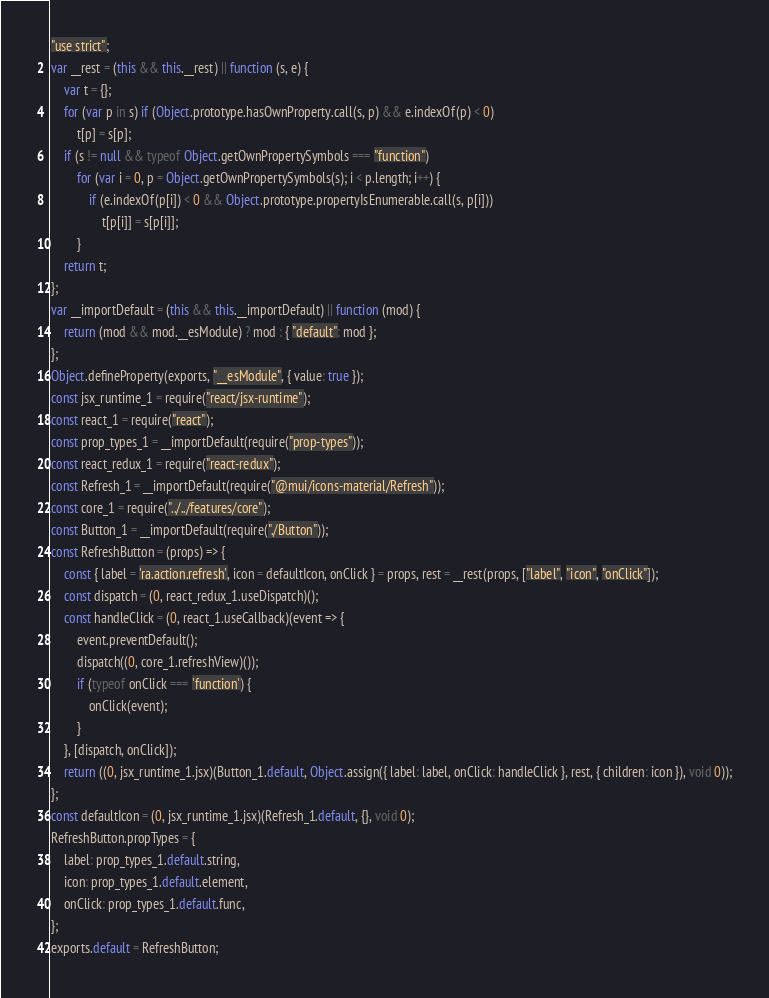Convert code to text. <code><loc_0><loc_0><loc_500><loc_500><_JavaScript_>"use strict";
var __rest = (this && this.__rest) || function (s, e) {
    var t = {};
    for (var p in s) if (Object.prototype.hasOwnProperty.call(s, p) && e.indexOf(p) < 0)
        t[p] = s[p];
    if (s != null && typeof Object.getOwnPropertySymbols === "function")
        for (var i = 0, p = Object.getOwnPropertySymbols(s); i < p.length; i++) {
            if (e.indexOf(p[i]) < 0 && Object.prototype.propertyIsEnumerable.call(s, p[i]))
                t[p[i]] = s[p[i]];
        }
    return t;
};
var __importDefault = (this && this.__importDefault) || function (mod) {
    return (mod && mod.__esModule) ? mod : { "default": mod };
};
Object.defineProperty(exports, "__esModule", { value: true });
const jsx_runtime_1 = require("react/jsx-runtime");
const react_1 = require("react");
const prop_types_1 = __importDefault(require("prop-types"));
const react_redux_1 = require("react-redux");
const Refresh_1 = __importDefault(require("@mui/icons-material/Refresh"));
const core_1 = require("../../features/core");
const Button_1 = __importDefault(require("./Button"));
const RefreshButton = (props) => {
    const { label = 'ra.action.refresh', icon = defaultIcon, onClick } = props, rest = __rest(props, ["label", "icon", "onClick"]);
    const dispatch = (0, react_redux_1.useDispatch)();
    const handleClick = (0, react_1.useCallback)(event => {
        event.preventDefault();
        dispatch((0, core_1.refreshView)());
        if (typeof onClick === 'function') {
            onClick(event);
        }
    }, [dispatch, onClick]);
    return ((0, jsx_runtime_1.jsx)(Button_1.default, Object.assign({ label: label, onClick: handleClick }, rest, { children: icon }), void 0));
};
const defaultIcon = (0, jsx_runtime_1.jsx)(Refresh_1.default, {}, void 0);
RefreshButton.propTypes = {
    label: prop_types_1.default.string,
    icon: prop_types_1.default.element,
    onClick: prop_types_1.default.func,
};
exports.default = RefreshButton;
</code> 